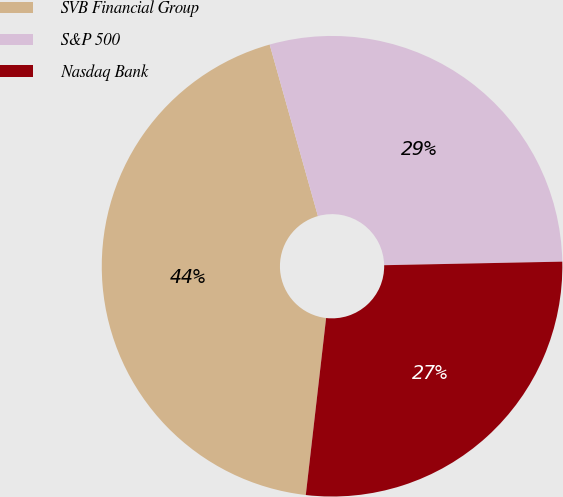Convert chart. <chart><loc_0><loc_0><loc_500><loc_500><pie_chart><fcel>SVB Financial Group<fcel>S&P 500<fcel>Nasdaq Bank<nl><fcel>43.82%<fcel>29.05%<fcel>27.14%<nl></chart> 